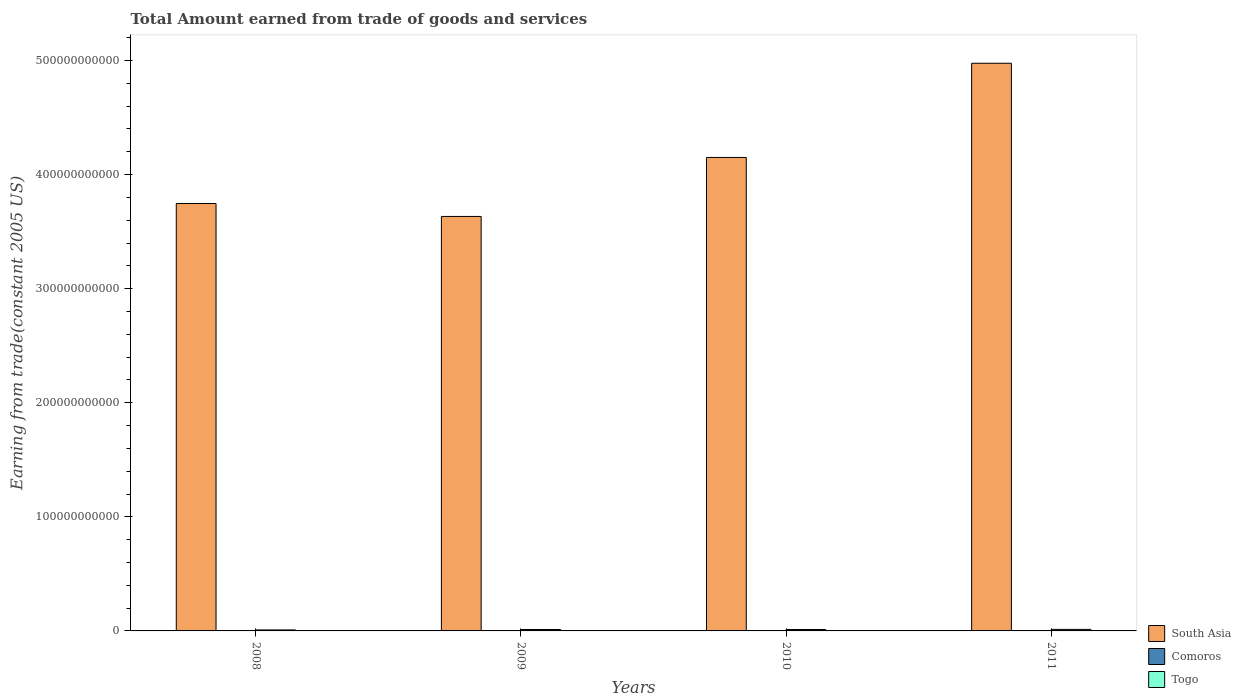How many groups of bars are there?
Make the answer very short. 4. Are the number of bars per tick equal to the number of legend labels?
Make the answer very short. Yes. Are the number of bars on each tick of the X-axis equal?
Provide a short and direct response. Yes. What is the label of the 3rd group of bars from the left?
Provide a succinct answer. 2010. What is the total amount earned by trading goods and services in Togo in 2010?
Your response must be concise. 1.25e+09. Across all years, what is the maximum total amount earned by trading goods and services in Togo?
Offer a terse response. 1.35e+09. Across all years, what is the minimum total amount earned by trading goods and services in Togo?
Make the answer very short. 8.85e+08. In which year was the total amount earned by trading goods and services in South Asia maximum?
Offer a very short reply. 2011. What is the total total amount earned by trading goods and services in South Asia in the graph?
Provide a succinct answer. 1.65e+12. What is the difference between the total amount earned by trading goods and services in Togo in 2008 and that in 2011?
Make the answer very short. -4.65e+08. What is the difference between the total amount earned by trading goods and services in Togo in 2010 and the total amount earned by trading goods and services in South Asia in 2009?
Offer a terse response. -3.62e+11. What is the average total amount earned by trading goods and services in South Asia per year?
Your answer should be compact. 4.13e+11. In the year 2010, what is the difference between the total amount earned by trading goods and services in Togo and total amount earned by trading goods and services in Comoros?
Keep it short and to the point. 9.81e+08. What is the ratio of the total amount earned by trading goods and services in South Asia in 2008 to that in 2011?
Offer a very short reply. 0.75. What is the difference between the highest and the second highest total amount earned by trading goods and services in Comoros?
Ensure brevity in your answer.  1.44e+07. What is the difference between the highest and the lowest total amount earned by trading goods and services in Togo?
Give a very brief answer. 4.65e+08. In how many years, is the total amount earned by trading goods and services in South Asia greater than the average total amount earned by trading goods and services in South Asia taken over all years?
Make the answer very short. 2. What does the 2nd bar from the left in 2009 represents?
Provide a short and direct response. Comoros. What does the 3rd bar from the right in 2008 represents?
Ensure brevity in your answer.  South Asia. How many bars are there?
Provide a short and direct response. 12. Are all the bars in the graph horizontal?
Offer a terse response. No. What is the difference between two consecutive major ticks on the Y-axis?
Offer a very short reply. 1.00e+11. Are the values on the major ticks of Y-axis written in scientific E-notation?
Make the answer very short. No. Does the graph contain any zero values?
Your response must be concise. No. Does the graph contain grids?
Your answer should be very brief. No. Where does the legend appear in the graph?
Provide a succinct answer. Bottom right. How many legend labels are there?
Keep it short and to the point. 3. How are the legend labels stacked?
Offer a terse response. Vertical. What is the title of the graph?
Ensure brevity in your answer.  Total Amount earned from trade of goods and services. Does "European Union" appear as one of the legend labels in the graph?
Offer a very short reply. No. What is the label or title of the Y-axis?
Give a very brief answer. Earning from trade(constant 2005 US). What is the Earning from trade(constant 2005 US) in South Asia in 2008?
Your answer should be very brief. 3.75e+11. What is the Earning from trade(constant 2005 US) of Comoros in 2008?
Your response must be concise. 2.22e+08. What is the Earning from trade(constant 2005 US) in Togo in 2008?
Provide a short and direct response. 8.85e+08. What is the Earning from trade(constant 2005 US) in South Asia in 2009?
Ensure brevity in your answer.  3.63e+11. What is the Earning from trade(constant 2005 US) of Comoros in 2009?
Your answer should be very brief. 2.21e+08. What is the Earning from trade(constant 2005 US) of Togo in 2009?
Offer a very short reply. 1.24e+09. What is the Earning from trade(constant 2005 US) in South Asia in 2010?
Offer a very short reply. 4.15e+11. What is the Earning from trade(constant 2005 US) of Comoros in 2010?
Offer a very short reply. 2.64e+08. What is the Earning from trade(constant 2005 US) of Togo in 2010?
Keep it short and to the point. 1.25e+09. What is the Earning from trade(constant 2005 US) of South Asia in 2011?
Provide a short and direct response. 4.98e+11. What is the Earning from trade(constant 2005 US) of Comoros in 2011?
Provide a short and direct response. 2.78e+08. What is the Earning from trade(constant 2005 US) of Togo in 2011?
Your answer should be compact. 1.35e+09. Across all years, what is the maximum Earning from trade(constant 2005 US) in South Asia?
Keep it short and to the point. 4.98e+11. Across all years, what is the maximum Earning from trade(constant 2005 US) of Comoros?
Your answer should be very brief. 2.78e+08. Across all years, what is the maximum Earning from trade(constant 2005 US) in Togo?
Ensure brevity in your answer.  1.35e+09. Across all years, what is the minimum Earning from trade(constant 2005 US) in South Asia?
Ensure brevity in your answer.  3.63e+11. Across all years, what is the minimum Earning from trade(constant 2005 US) in Comoros?
Provide a short and direct response. 2.21e+08. Across all years, what is the minimum Earning from trade(constant 2005 US) in Togo?
Your response must be concise. 8.85e+08. What is the total Earning from trade(constant 2005 US) in South Asia in the graph?
Give a very brief answer. 1.65e+12. What is the total Earning from trade(constant 2005 US) of Comoros in the graph?
Make the answer very short. 9.86e+08. What is the total Earning from trade(constant 2005 US) in Togo in the graph?
Make the answer very short. 4.72e+09. What is the difference between the Earning from trade(constant 2005 US) in South Asia in 2008 and that in 2009?
Keep it short and to the point. 1.13e+1. What is the difference between the Earning from trade(constant 2005 US) in Comoros in 2008 and that in 2009?
Provide a short and direct response. 1.13e+06. What is the difference between the Earning from trade(constant 2005 US) of Togo in 2008 and that in 2009?
Offer a very short reply. -3.56e+08. What is the difference between the Earning from trade(constant 2005 US) of South Asia in 2008 and that in 2010?
Offer a terse response. -4.04e+1. What is the difference between the Earning from trade(constant 2005 US) of Comoros in 2008 and that in 2010?
Your response must be concise. -4.16e+07. What is the difference between the Earning from trade(constant 2005 US) of Togo in 2008 and that in 2010?
Your response must be concise. -3.60e+08. What is the difference between the Earning from trade(constant 2005 US) of South Asia in 2008 and that in 2011?
Ensure brevity in your answer.  -1.23e+11. What is the difference between the Earning from trade(constant 2005 US) in Comoros in 2008 and that in 2011?
Your answer should be very brief. -5.60e+07. What is the difference between the Earning from trade(constant 2005 US) in Togo in 2008 and that in 2011?
Your response must be concise. -4.65e+08. What is the difference between the Earning from trade(constant 2005 US) of South Asia in 2009 and that in 2010?
Your response must be concise. -5.17e+1. What is the difference between the Earning from trade(constant 2005 US) of Comoros in 2009 and that in 2010?
Keep it short and to the point. -4.27e+07. What is the difference between the Earning from trade(constant 2005 US) of Togo in 2009 and that in 2010?
Offer a very short reply. -4.25e+06. What is the difference between the Earning from trade(constant 2005 US) of South Asia in 2009 and that in 2011?
Provide a succinct answer. -1.34e+11. What is the difference between the Earning from trade(constant 2005 US) in Comoros in 2009 and that in 2011?
Your answer should be very brief. -5.71e+07. What is the difference between the Earning from trade(constant 2005 US) of Togo in 2009 and that in 2011?
Offer a terse response. -1.09e+08. What is the difference between the Earning from trade(constant 2005 US) of South Asia in 2010 and that in 2011?
Offer a terse response. -8.26e+1. What is the difference between the Earning from trade(constant 2005 US) in Comoros in 2010 and that in 2011?
Make the answer very short. -1.44e+07. What is the difference between the Earning from trade(constant 2005 US) of Togo in 2010 and that in 2011?
Your response must be concise. -1.04e+08. What is the difference between the Earning from trade(constant 2005 US) of South Asia in 2008 and the Earning from trade(constant 2005 US) of Comoros in 2009?
Give a very brief answer. 3.74e+11. What is the difference between the Earning from trade(constant 2005 US) of South Asia in 2008 and the Earning from trade(constant 2005 US) of Togo in 2009?
Provide a short and direct response. 3.73e+11. What is the difference between the Earning from trade(constant 2005 US) of Comoros in 2008 and the Earning from trade(constant 2005 US) of Togo in 2009?
Give a very brief answer. -1.02e+09. What is the difference between the Earning from trade(constant 2005 US) in South Asia in 2008 and the Earning from trade(constant 2005 US) in Comoros in 2010?
Your answer should be very brief. 3.74e+11. What is the difference between the Earning from trade(constant 2005 US) of South Asia in 2008 and the Earning from trade(constant 2005 US) of Togo in 2010?
Provide a short and direct response. 3.73e+11. What is the difference between the Earning from trade(constant 2005 US) of Comoros in 2008 and the Earning from trade(constant 2005 US) of Togo in 2010?
Keep it short and to the point. -1.02e+09. What is the difference between the Earning from trade(constant 2005 US) of South Asia in 2008 and the Earning from trade(constant 2005 US) of Comoros in 2011?
Ensure brevity in your answer.  3.74e+11. What is the difference between the Earning from trade(constant 2005 US) of South Asia in 2008 and the Earning from trade(constant 2005 US) of Togo in 2011?
Offer a terse response. 3.73e+11. What is the difference between the Earning from trade(constant 2005 US) in Comoros in 2008 and the Earning from trade(constant 2005 US) in Togo in 2011?
Your answer should be very brief. -1.13e+09. What is the difference between the Earning from trade(constant 2005 US) of South Asia in 2009 and the Earning from trade(constant 2005 US) of Comoros in 2010?
Offer a very short reply. 3.63e+11. What is the difference between the Earning from trade(constant 2005 US) in South Asia in 2009 and the Earning from trade(constant 2005 US) in Togo in 2010?
Offer a very short reply. 3.62e+11. What is the difference between the Earning from trade(constant 2005 US) of Comoros in 2009 and the Earning from trade(constant 2005 US) of Togo in 2010?
Keep it short and to the point. -1.02e+09. What is the difference between the Earning from trade(constant 2005 US) in South Asia in 2009 and the Earning from trade(constant 2005 US) in Comoros in 2011?
Your response must be concise. 3.63e+11. What is the difference between the Earning from trade(constant 2005 US) of South Asia in 2009 and the Earning from trade(constant 2005 US) of Togo in 2011?
Provide a short and direct response. 3.62e+11. What is the difference between the Earning from trade(constant 2005 US) in Comoros in 2009 and the Earning from trade(constant 2005 US) in Togo in 2011?
Your answer should be compact. -1.13e+09. What is the difference between the Earning from trade(constant 2005 US) in South Asia in 2010 and the Earning from trade(constant 2005 US) in Comoros in 2011?
Your response must be concise. 4.15e+11. What is the difference between the Earning from trade(constant 2005 US) of South Asia in 2010 and the Earning from trade(constant 2005 US) of Togo in 2011?
Ensure brevity in your answer.  4.14e+11. What is the difference between the Earning from trade(constant 2005 US) in Comoros in 2010 and the Earning from trade(constant 2005 US) in Togo in 2011?
Give a very brief answer. -1.09e+09. What is the average Earning from trade(constant 2005 US) of South Asia per year?
Make the answer very short. 4.13e+11. What is the average Earning from trade(constant 2005 US) of Comoros per year?
Make the answer very short. 2.47e+08. What is the average Earning from trade(constant 2005 US) in Togo per year?
Provide a short and direct response. 1.18e+09. In the year 2008, what is the difference between the Earning from trade(constant 2005 US) in South Asia and Earning from trade(constant 2005 US) in Comoros?
Provide a succinct answer. 3.74e+11. In the year 2008, what is the difference between the Earning from trade(constant 2005 US) in South Asia and Earning from trade(constant 2005 US) in Togo?
Offer a terse response. 3.74e+11. In the year 2008, what is the difference between the Earning from trade(constant 2005 US) of Comoros and Earning from trade(constant 2005 US) of Togo?
Provide a succinct answer. -6.63e+08. In the year 2009, what is the difference between the Earning from trade(constant 2005 US) in South Asia and Earning from trade(constant 2005 US) in Comoros?
Give a very brief answer. 3.63e+11. In the year 2009, what is the difference between the Earning from trade(constant 2005 US) in South Asia and Earning from trade(constant 2005 US) in Togo?
Make the answer very short. 3.62e+11. In the year 2009, what is the difference between the Earning from trade(constant 2005 US) in Comoros and Earning from trade(constant 2005 US) in Togo?
Offer a very short reply. -1.02e+09. In the year 2010, what is the difference between the Earning from trade(constant 2005 US) of South Asia and Earning from trade(constant 2005 US) of Comoros?
Offer a very short reply. 4.15e+11. In the year 2010, what is the difference between the Earning from trade(constant 2005 US) of South Asia and Earning from trade(constant 2005 US) of Togo?
Keep it short and to the point. 4.14e+11. In the year 2010, what is the difference between the Earning from trade(constant 2005 US) of Comoros and Earning from trade(constant 2005 US) of Togo?
Offer a very short reply. -9.81e+08. In the year 2011, what is the difference between the Earning from trade(constant 2005 US) of South Asia and Earning from trade(constant 2005 US) of Comoros?
Your answer should be very brief. 4.97e+11. In the year 2011, what is the difference between the Earning from trade(constant 2005 US) of South Asia and Earning from trade(constant 2005 US) of Togo?
Provide a short and direct response. 4.96e+11. In the year 2011, what is the difference between the Earning from trade(constant 2005 US) of Comoros and Earning from trade(constant 2005 US) of Togo?
Provide a succinct answer. -1.07e+09. What is the ratio of the Earning from trade(constant 2005 US) in South Asia in 2008 to that in 2009?
Ensure brevity in your answer.  1.03. What is the ratio of the Earning from trade(constant 2005 US) of Comoros in 2008 to that in 2009?
Give a very brief answer. 1.01. What is the ratio of the Earning from trade(constant 2005 US) in Togo in 2008 to that in 2009?
Your response must be concise. 0.71. What is the ratio of the Earning from trade(constant 2005 US) of South Asia in 2008 to that in 2010?
Ensure brevity in your answer.  0.9. What is the ratio of the Earning from trade(constant 2005 US) of Comoros in 2008 to that in 2010?
Give a very brief answer. 0.84. What is the ratio of the Earning from trade(constant 2005 US) of Togo in 2008 to that in 2010?
Make the answer very short. 0.71. What is the ratio of the Earning from trade(constant 2005 US) of South Asia in 2008 to that in 2011?
Provide a succinct answer. 0.75. What is the ratio of the Earning from trade(constant 2005 US) of Comoros in 2008 to that in 2011?
Offer a terse response. 0.8. What is the ratio of the Earning from trade(constant 2005 US) in Togo in 2008 to that in 2011?
Provide a short and direct response. 0.66. What is the ratio of the Earning from trade(constant 2005 US) in South Asia in 2009 to that in 2010?
Provide a succinct answer. 0.88. What is the ratio of the Earning from trade(constant 2005 US) of Comoros in 2009 to that in 2010?
Offer a very short reply. 0.84. What is the ratio of the Earning from trade(constant 2005 US) in South Asia in 2009 to that in 2011?
Your answer should be compact. 0.73. What is the ratio of the Earning from trade(constant 2005 US) of Comoros in 2009 to that in 2011?
Keep it short and to the point. 0.79. What is the ratio of the Earning from trade(constant 2005 US) of Togo in 2009 to that in 2011?
Offer a terse response. 0.92. What is the ratio of the Earning from trade(constant 2005 US) of South Asia in 2010 to that in 2011?
Your answer should be very brief. 0.83. What is the ratio of the Earning from trade(constant 2005 US) of Comoros in 2010 to that in 2011?
Offer a terse response. 0.95. What is the ratio of the Earning from trade(constant 2005 US) in Togo in 2010 to that in 2011?
Make the answer very short. 0.92. What is the difference between the highest and the second highest Earning from trade(constant 2005 US) of South Asia?
Offer a terse response. 8.26e+1. What is the difference between the highest and the second highest Earning from trade(constant 2005 US) of Comoros?
Provide a succinct answer. 1.44e+07. What is the difference between the highest and the second highest Earning from trade(constant 2005 US) of Togo?
Your answer should be very brief. 1.04e+08. What is the difference between the highest and the lowest Earning from trade(constant 2005 US) of South Asia?
Make the answer very short. 1.34e+11. What is the difference between the highest and the lowest Earning from trade(constant 2005 US) in Comoros?
Give a very brief answer. 5.71e+07. What is the difference between the highest and the lowest Earning from trade(constant 2005 US) in Togo?
Your response must be concise. 4.65e+08. 